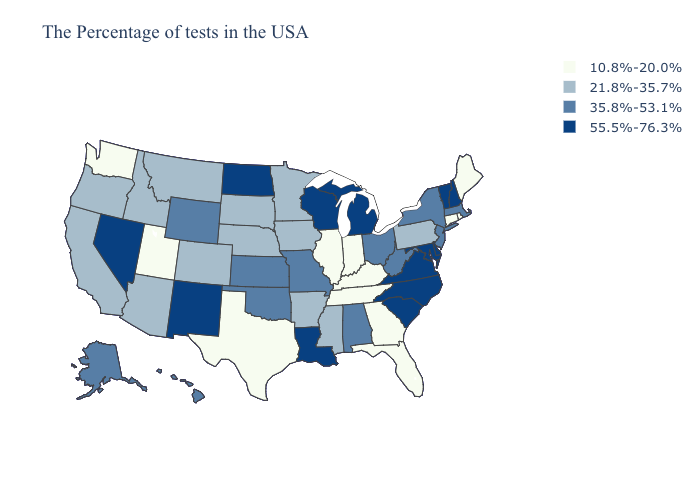Does Georgia have the lowest value in the South?
Answer briefly. Yes. Does Maryland have the lowest value in the South?
Short answer required. No. What is the value of Montana?
Concise answer only. 21.8%-35.7%. Does the map have missing data?
Keep it brief. No. Does the map have missing data?
Quick response, please. No. What is the value of Indiana?
Keep it brief. 10.8%-20.0%. What is the lowest value in the USA?
Give a very brief answer. 10.8%-20.0%. Does Wisconsin have the highest value in the USA?
Quick response, please. Yes. Name the states that have a value in the range 35.8%-53.1%?
Write a very short answer. Massachusetts, New York, New Jersey, West Virginia, Ohio, Alabama, Missouri, Kansas, Oklahoma, Wyoming, Alaska, Hawaii. What is the value of South Dakota?
Keep it brief. 21.8%-35.7%. Name the states that have a value in the range 55.5%-76.3%?
Quick response, please. New Hampshire, Vermont, Delaware, Maryland, Virginia, North Carolina, South Carolina, Michigan, Wisconsin, Louisiana, North Dakota, New Mexico, Nevada. Among the states that border Wisconsin , does Michigan have the lowest value?
Quick response, please. No. What is the value of New Jersey?
Concise answer only. 35.8%-53.1%. Name the states that have a value in the range 55.5%-76.3%?
Be succinct. New Hampshire, Vermont, Delaware, Maryland, Virginia, North Carolina, South Carolina, Michigan, Wisconsin, Louisiana, North Dakota, New Mexico, Nevada. Name the states that have a value in the range 21.8%-35.7%?
Quick response, please. Pennsylvania, Mississippi, Arkansas, Minnesota, Iowa, Nebraska, South Dakota, Colorado, Montana, Arizona, Idaho, California, Oregon. 